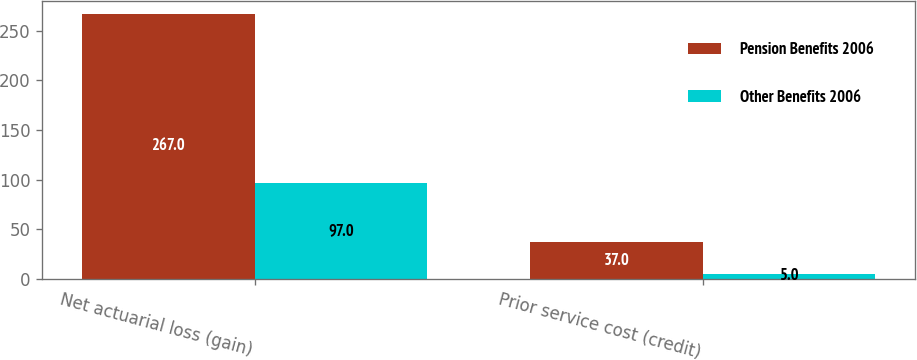Convert chart to OTSL. <chart><loc_0><loc_0><loc_500><loc_500><stacked_bar_chart><ecel><fcel>Net actuarial loss (gain)<fcel>Prior service cost (credit)<nl><fcel>Pension Benefits 2006<fcel>267<fcel>37<nl><fcel>Other Benefits 2006<fcel>97<fcel>5<nl></chart> 